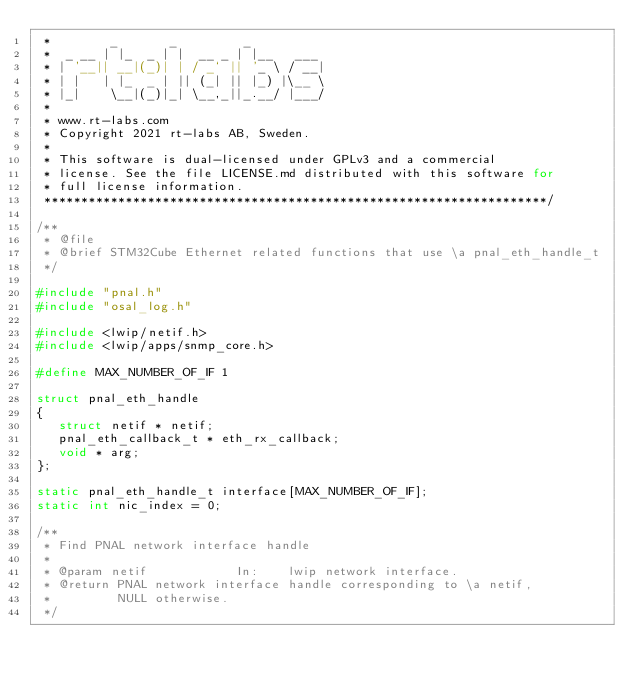<code> <loc_0><loc_0><loc_500><loc_500><_C_> *        _       _         _
 *  _ __ | |_  _ | |  __ _ | |__   ___
 * | '__|| __|(_)| | / _` || '_ \ / __|
 * | |   | |_  _ | || (_| || |_) |\__ \
 * |_|    \__|(_)|_| \__,_||_.__/ |___/
 *
 * www.rt-labs.com
 * Copyright 2021 rt-labs AB, Sweden.
 *
 * This software is dual-licensed under GPLv3 and a commercial
 * license. See the file LICENSE.md distributed with this software for
 * full license information.
 ********************************************************************/

/**
 * @file
 * @brief STM32Cube Ethernet related functions that use \a pnal_eth_handle_t
 */

#include "pnal.h"
#include "osal_log.h"

#include <lwip/netif.h>
#include <lwip/apps/snmp_core.h>

#define MAX_NUMBER_OF_IF 1

struct pnal_eth_handle
{
   struct netif * netif;
   pnal_eth_callback_t * eth_rx_callback;
   void * arg;
};

static pnal_eth_handle_t interface[MAX_NUMBER_OF_IF];
static int nic_index = 0;

/**
 * Find PNAL network interface handle
 *
 * @param netif            In:    lwip network interface.
 * @return PNAL network interface handle corresponding to \a netif,
 *         NULL otherwise.
 */</code> 